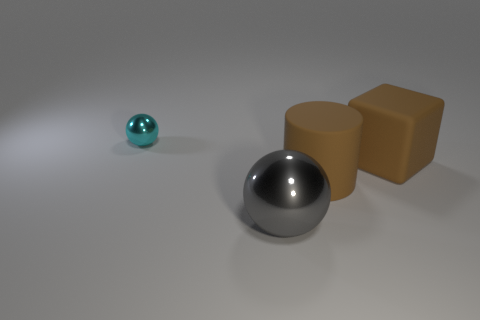Add 1 shiny objects. How many objects exist? 5 Subtract all blocks. How many objects are left? 3 Add 2 big brown cylinders. How many big brown cylinders are left? 3 Add 2 tiny metallic things. How many tiny metallic things exist? 3 Subtract 0 green spheres. How many objects are left? 4 Subtract all yellow shiny balls. Subtract all blocks. How many objects are left? 3 